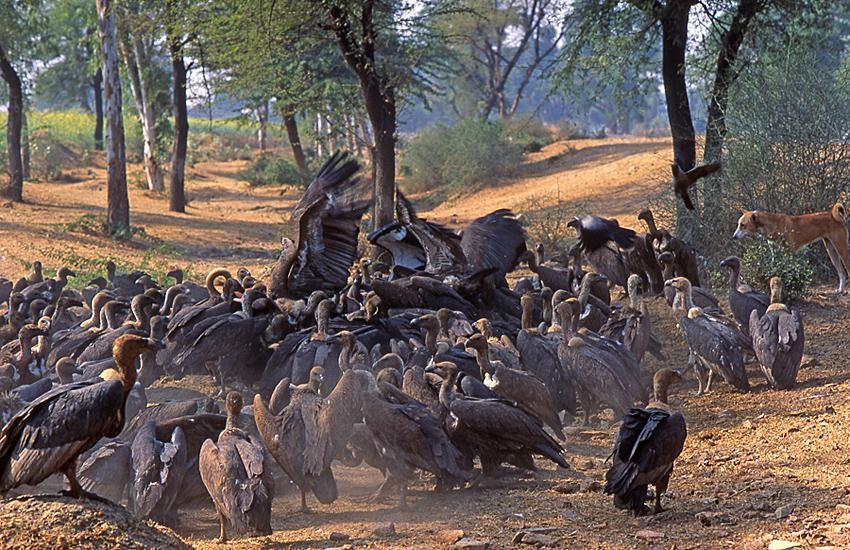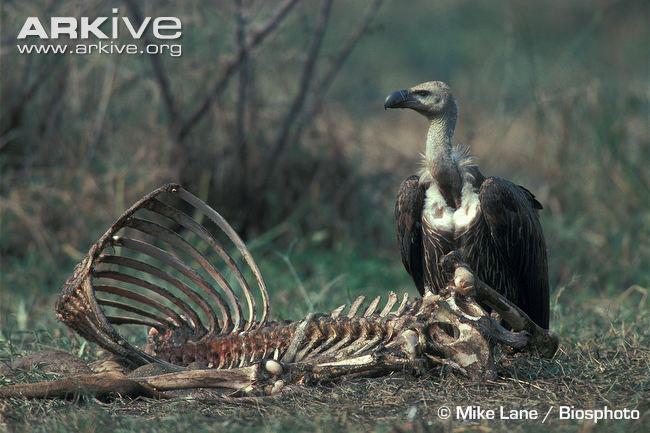The first image is the image on the left, the second image is the image on the right. Given the left and right images, does the statement "The left image contains exactly two vultures." hold true? Answer yes or no. No. 